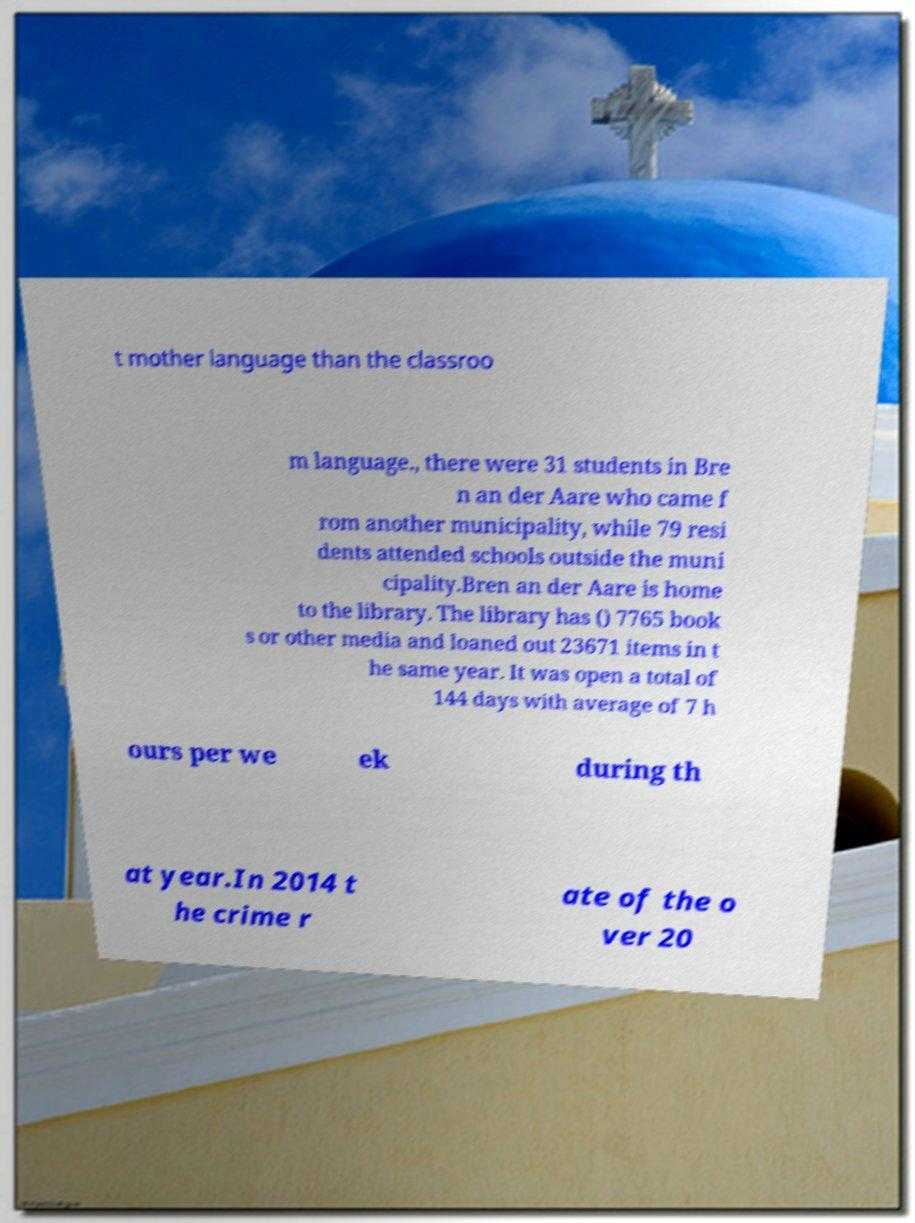I need the written content from this picture converted into text. Can you do that? t mother language than the classroo m language., there were 31 students in Bre n an der Aare who came f rom another municipality, while 79 resi dents attended schools outside the muni cipality.Bren an der Aare is home to the library. The library has () 7765 book s or other media and loaned out 23671 items in t he same year. It was open a total of 144 days with average of 7 h ours per we ek during th at year.In 2014 t he crime r ate of the o ver 20 